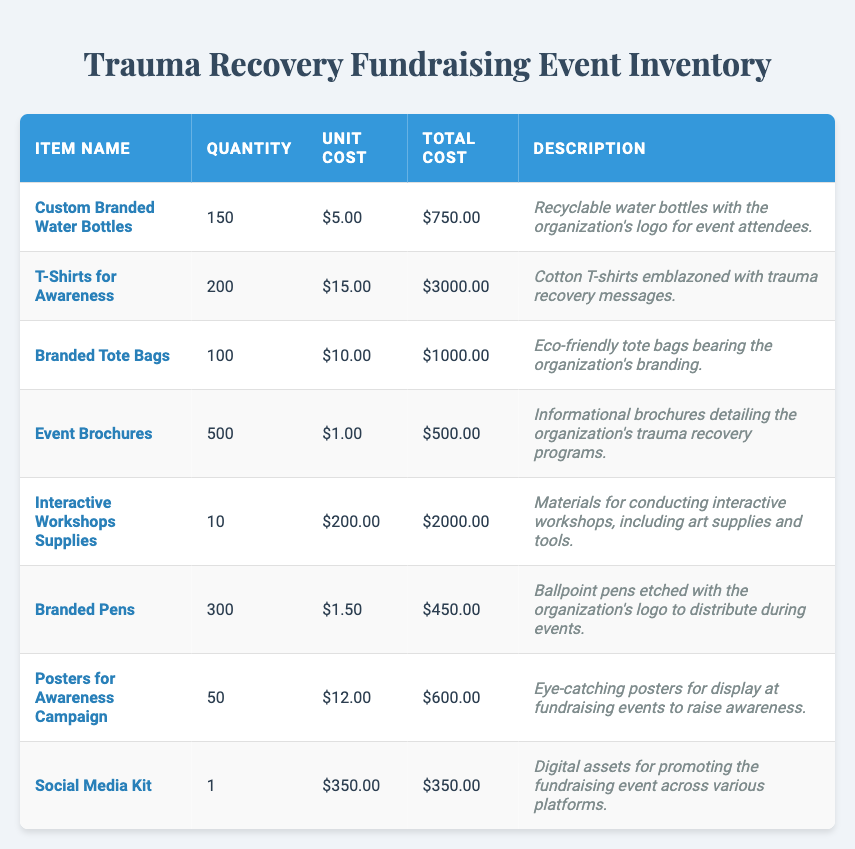What is the total cost of the T-Shirts for Awareness? By looking at the table, the total cost for the T-Shirts for Awareness is already provided as $3000.
Answer: 3000 How many Custom Branded Water Bottles are available? The quantity of Custom Branded Water Bottles is listed in the table as 150.
Answer: 150 Are there more Branded Pens than Branded Tote Bags? The quantity of Branded Pens is 300, while Branded Tote Bags show a quantity of 100. Yes, there are more Branded Pens than Branded Tote Bags.
Answer: Yes What is the total cost for all interactive workshop supplies? The total cost for the Interactive Workshops Supplies is given as $2000. Since there is only one entry for this item, the total remains the same.
Answer: 2000 What is the average unit cost of the items listed? The total unit costs from the items are: 5, 15, 10, 1, 200, 1.5, 12, and 350. Adding these gives 594. Since there are 8 items, the average unit cost is 594 divided by 8, which equals 74.25.
Answer: 74.25 What percentage of the total inventory cost is made up by the Branded Tote Bags? The total costs in the inventory are: 750, 3000, 1000, 500, 2000, 450, 600, and 350. Summing these gives a total cost of $8,150. The total cost for Branded Tote Bags is $1000. To find the percentage, divide 1000 by 8150 and multiply by 100, yielding approximately 12.27%.
Answer: 12.27% Is the quantity of Event Brochures larger than the combined quantity of Custom Branded Water Bottles and T-Shirts for Awareness? The quantity of Event Brochures is 500, the quantity of Custom Branded Water Bottles is 150, and T-Shirts for Awareness is 200. Adding 150 and 200 gives a total of 350. Since 500 is greater than 350, the statement is true.
Answer: Yes Which item has the highest unit cost, and what is that cost? Reviewing the unit costs, the highest is the Interactive Workshops Supplies at $200.
Answer: 200 How many more Branded Pens are there than Posters for Awareness Campaign? The quantity of Branded Pens is 300, while Posters for Awareness Campaign shows a quantity of 50. The difference is 300 minus 50, equating to 250 more Branded Pens.
Answer: 250 